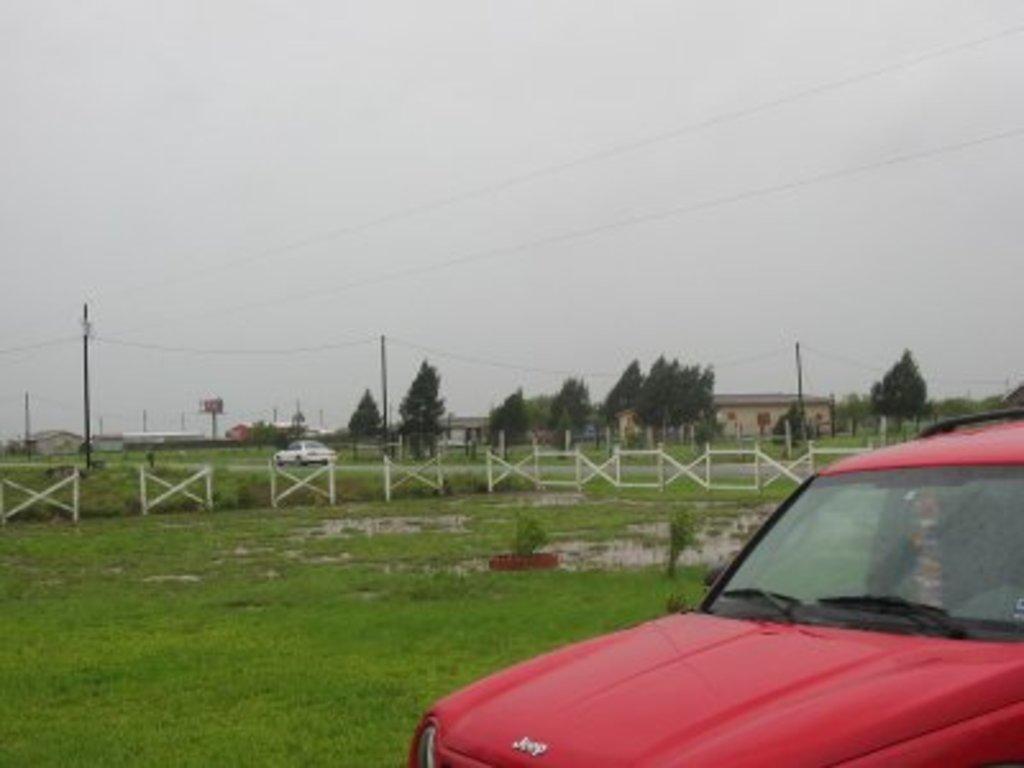How would you summarize this image in a sentence or two? In the picture we can see red color car which is parked, there is wooden fencing, in the background of the picture there is a car which is moving on road, there are some trees and houses and top of the picture there are some wires and there is cloudy sky. 